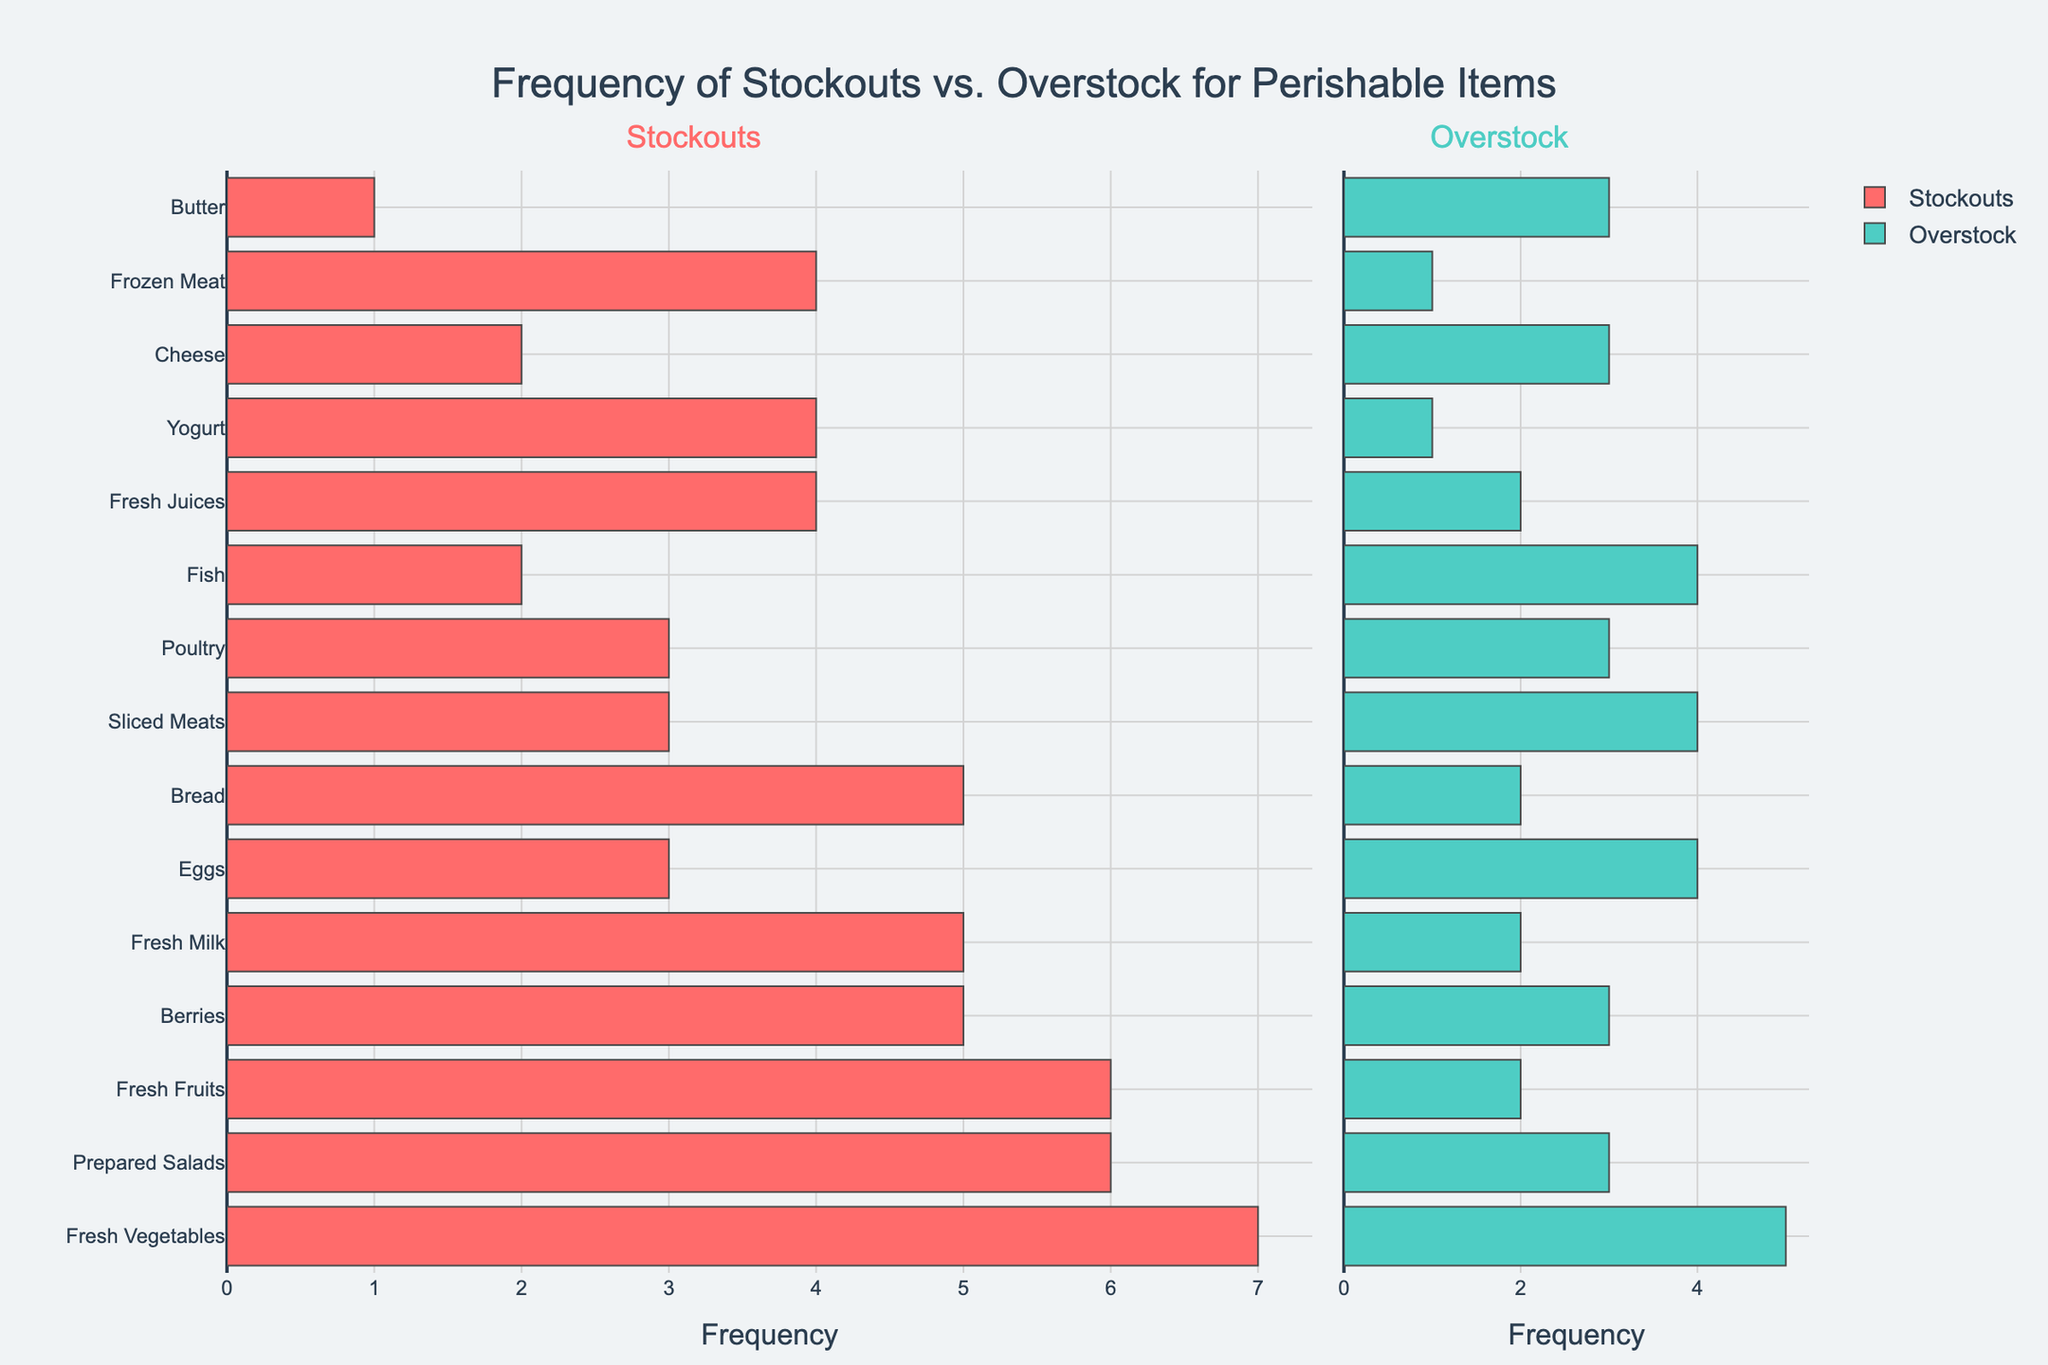What's the total frequency of stockouts and overstock for Fresh Vegetables? To find the total frequency of stockouts and overstock for Fresh Vegetables, add the number of stockouts and the number of overstock occurrences. The figure shows Fresh Vegetables has 7 stockouts and 5 overstock. Therefore, the total frequency is 7 + 5 = 12.
Answer: 12 Which item has the highest number of stockouts and how many are there? By observing the lengths of the bars in the Stockouts section, Fresh Vegetables has the highest number of stockouts with a value of 7.
Answer: Fresh Vegetables, 7 Compare the occurrences of stockouts and overstock for Fresh Juices. Which is higher? Check the bar lengths for Fresh Juices in both the Stockouts and Overstock sections. Fresh Juices has 4 stockouts and 2 overstock. Since 4 is greater than 2, the occurrences of stockouts are higher than overstock for Fresh Juices.
Answer: Stockouts What’s the difference in the number of stockouts between Fresh Fruits and Fresh Milk? Look at the Stockouts section and find the values for Fresh Fruits (6) and Fresh Milk (5). The difference is calculated by subtracting the smaller number from the larger number: 6 - 5 = 1.
Answer: 1 Which item has an equal number of stockouts and overstock? Look for an item where the lengths of the bars in the Stockouts and Overstock sections are the same. Poultry has 3 stockouts and 3 overstock, indicating they are equal.
Answer: Poultry How many items have more overstock occurrences than stockouts? Visually compare the lengths of the bars for each item. Eggs, Cheese, Fish, Sliced Meats, and Butter have their overstock bars longer than their stockout bars. Therefore, there are 5 such items.
Answer: 5 What is the combined total of stockouts and overstock for Bread and Cheese? Find the bars for Bread and Cheese. Bread has 5 stockouts and 2 overstock, while Cheese has 2 stockouts and 3 overstock. Sum these values: (5 + 2) + (2 + 3) = 12.
Answer: 12 Which item has the lowest total occurrences of stockouts and overstock? Look for the shortest combined lengths of both stockouts and overstock bars. Yogurt has 4 stockouts and 1 overstock (total 5), which is the lowest sum.
Answer: Yogurt What’s the average number of stockouts for Dairy products (Fresh Milk, Cheese, Yogurt, Butter)? Find the stockout numbers for Fresh Milk (5), Cheese (2), Yogurt (4), and Butter (1). Sum these values and divide by the number of items: (5 + 2 + 4 + 1) / 4 = 3.
Answer: 3 How does the stockout situation for Fresh Fruits compare to Prepared Salads? Compare the bars in the Stockouts section. Fresh Fruits have 6 stockouts, while Prepared Salads have 6. Both items have an equal number of stockouts.
Answer: Equal 